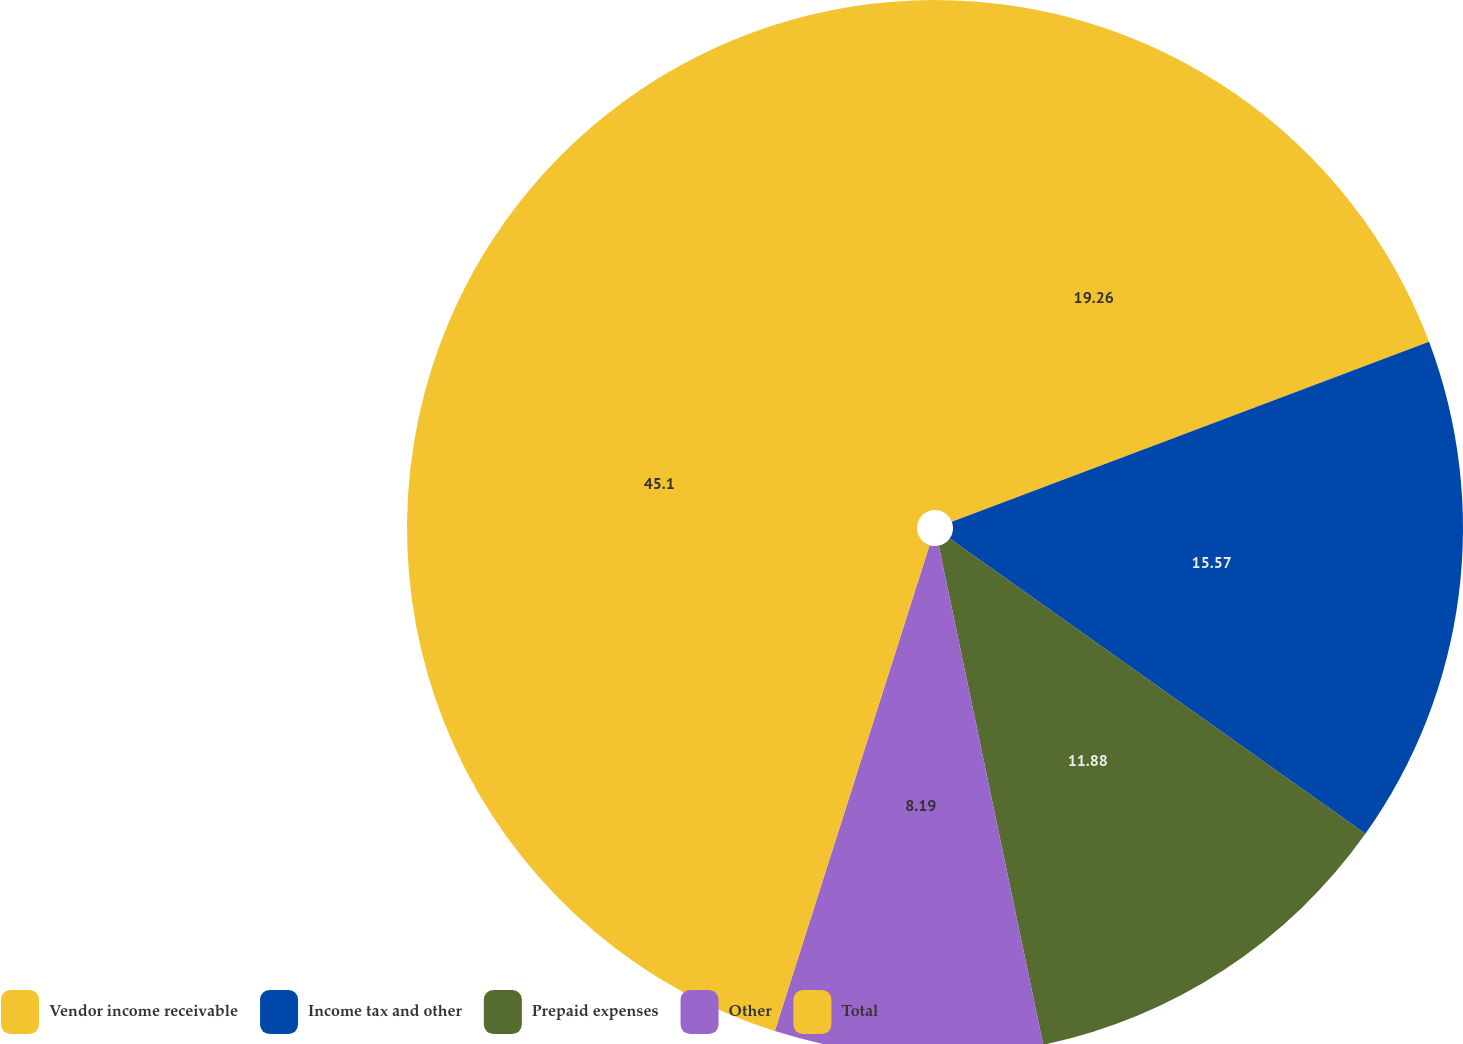Convert chart to OTSL. <chart><loc_0><loc_0><loc_500><loc_500><pie_chart><fcel>Vendor income receivable<fcel>Income tax and other<fcel>Prepaid expenses<fcel>Other<fcel>Total<nl><fcel>19.26%<fcel>15.57%<fcel>11.88%<fcel>8.19%<fcel>45.09%<nl></chart> 